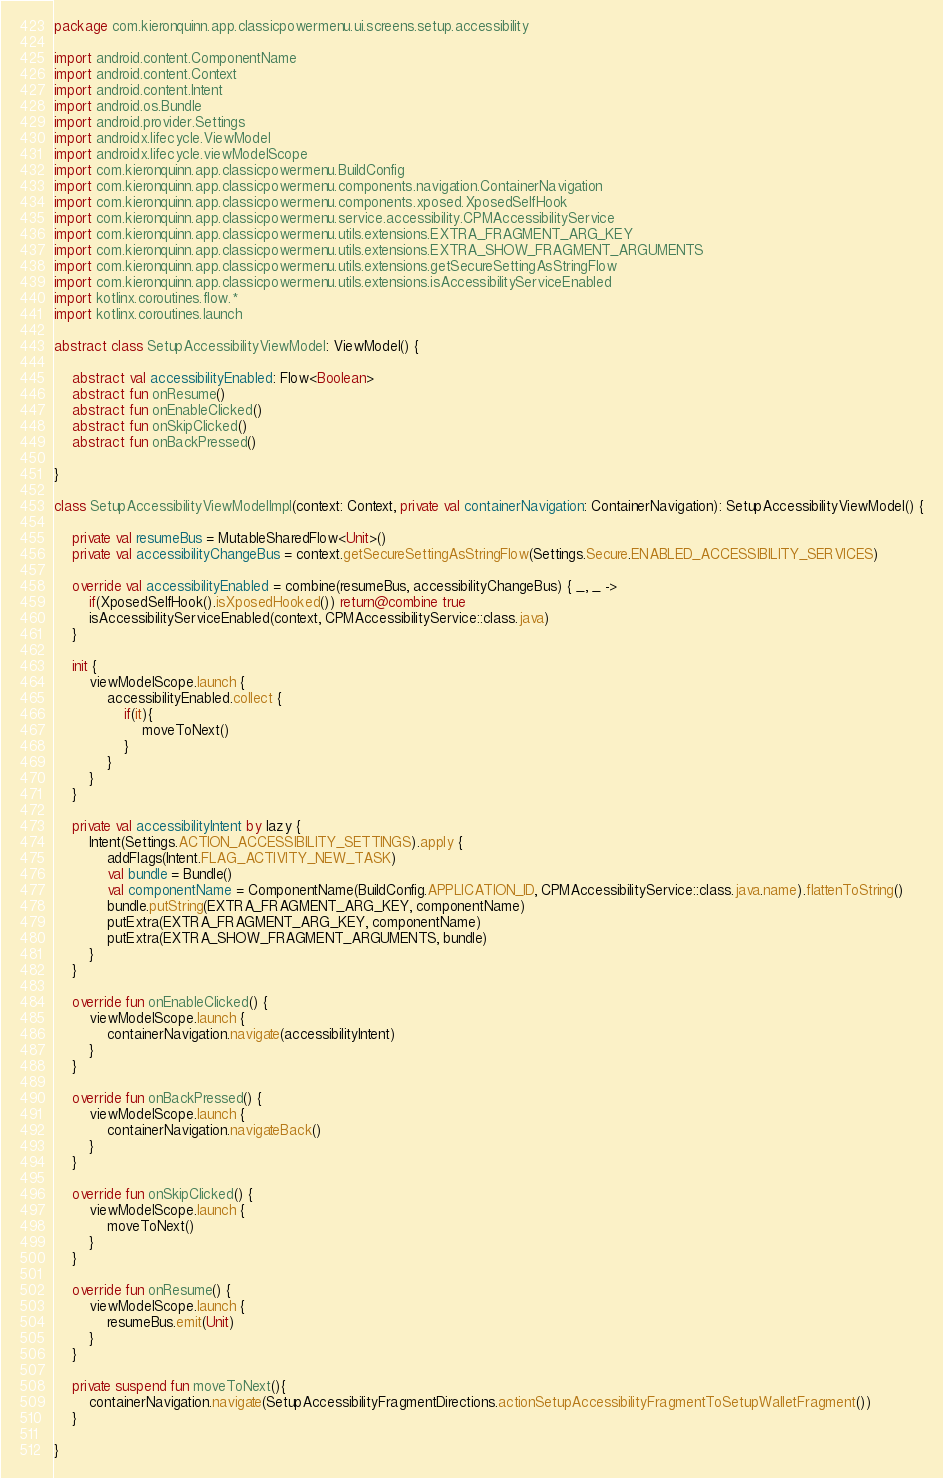<code> <loc_0><loc_0><loc_500><loc_500><_Kotlin_>package com.kieronquinn.app.classicpowermenu.ui.screens.setup.accessibility

import android.content.ComponentName
import android.content.Context
import android.content.Intent
import android.os.Bundle
import android.provider.Settings
import androidx.lifecycle.ViewModel
import androidx.lifecycle.viewModelScope
import com.kieronquinn.app.classicpowermenu.BuildConfig
import com.kieronquinn.app.classicpowermenu.components.navigation.ContainerNavigation
import com.kieronquinn.app.classicpowermenu.components.xposed.XposedSelfHook
import com.kieronquinn.app.classicpowermenu.service.accessibility.CPMAccessibilityService
import com.kieronquinn.app.classicpowermenu.utils.extensions.EXTRA_FRAGMENT_ARG_KEY
import com.kieronquinn.app.classicpowermenu.utils.extensions.EXTRA_SHOW_FRAGMENT_ARGUMENTS
import com.kieronquinn.app.classicpowermenu.utils.extensions.getSecureSettingAsStringFlow
import com.kieronquinn.app.classicpowermenu.utils.extensions.isAccessibilityServiceEnabled
import kotlinx.coroutines.flow.*
import kotlinx.coroutines.launch

abstract class SetupAccessibilityViewModel: ViewModel() {

    abstract val accessibilityEnabled: Flow<Boolean>
    abstract fun onResume()
    abstract fun onEnableClicked()
    abstract fun onSkipClicked()
    abstract fun onBackPressed()

}

class SetupAccessibilityViewModelImpl(context: Context, private val containerNavigation: ContainerNavigation): SetupAccessibilityViewModel() {

    private val resumeBus = MutableSharedFlow<Unit>()
    private val accessibilityChangeBus = context.getSecureSettingAsStringFlow(Settings.Secure.ENABLED_ACCESSIBILITY_SERVICES)

    override val accessibilityEnabled = combine(resumeBus, accessibilityChangeBus) { _, _ ->
        if(XposedSelfHook().isXposedHooked()) return@combine true
        isAccessibilityServiceEnabled(context, CPMAccessibilityService::class.java)
    }

    init {
        viewModelScope.launch {
            accessibilityEnabled.collect {
                if(it){
                    moveToNext()
                }
            }
        }
    }

    private val accessibilityIntent by lazy {
        Intent(Settings.ACTION_ACCESSIBILITY_SETTINGS).apply {
            addFlags(Intent.FLAG_ACTIVITY_NEW_TASK)
            val bundle = Bundle()
            val componentName = ComponentName(BuildConfig.APPLICATION_ID, CPMAccessibilityService::class.java.name).flattenToString()
            bundle.putString(EXTRA_FRAGMENT_ARG_KEY, componentName)
            putExtra(EXTRA_FRAGMENT_ARG_KEY, componentName)
            putExtra(EXTRA_SHOW_FRAGMENT_ARGUMENTS, bundle)
        }
    }

    override fun onEnableClicked() {
        viewModelScope.launch {
            containerNavigation.navigate(accessibilityIntent)
        }
    }

    override fun onBackPressed() {
        viewModelScope.launch {
            containerNavigation.navigateBack()
        }
    }

    override fun onSkipClicked() {
        viewModelScope.launch {
            moveToNext()
        }
    }

    override fun onResume() {
        viewModelScope.launch {
            resumeBus.emit(Unit)
        }
    }

    private suspend fun moveToNext(){
        containerNavigation.navigate(SetupAccessibilityFragmentDirections.actionSetupAccessibilityFragmentToSetupWalletFragment())
    }

}</code> 